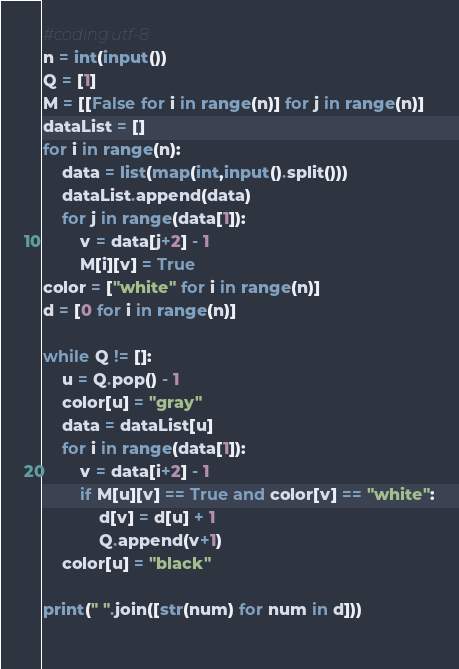<code> <loc_0><loc_0><loc_500><loc_500><_Python_>#coding:utf-8
n = int(input())
Q = [1]
M = [[False for i in range(n)] for j in range(n)]
dataList = []
for i in range(n):
    data = list(map(int,input().split()))
    dataList.append(data)
    for j in range(data[1]):
        v = data[j+2] - 1
        M[i][v] = True
color = ["white" for i in range(n)]
d = [0 for i in range(n)]

while Q != []:
    u = Q.pop() - 1
    color[u] = "gray"
    data = dataList[u]
    for i in range(data[1]):
        v = data[i+2] - 1
        if M[u][v] == True and color[v] == "white":
            d[v] = d[u] + 1
            Q.append(v+1)
    color[u] = "black"

print(" ".join([str(num) for num in d]))
    

</code> 